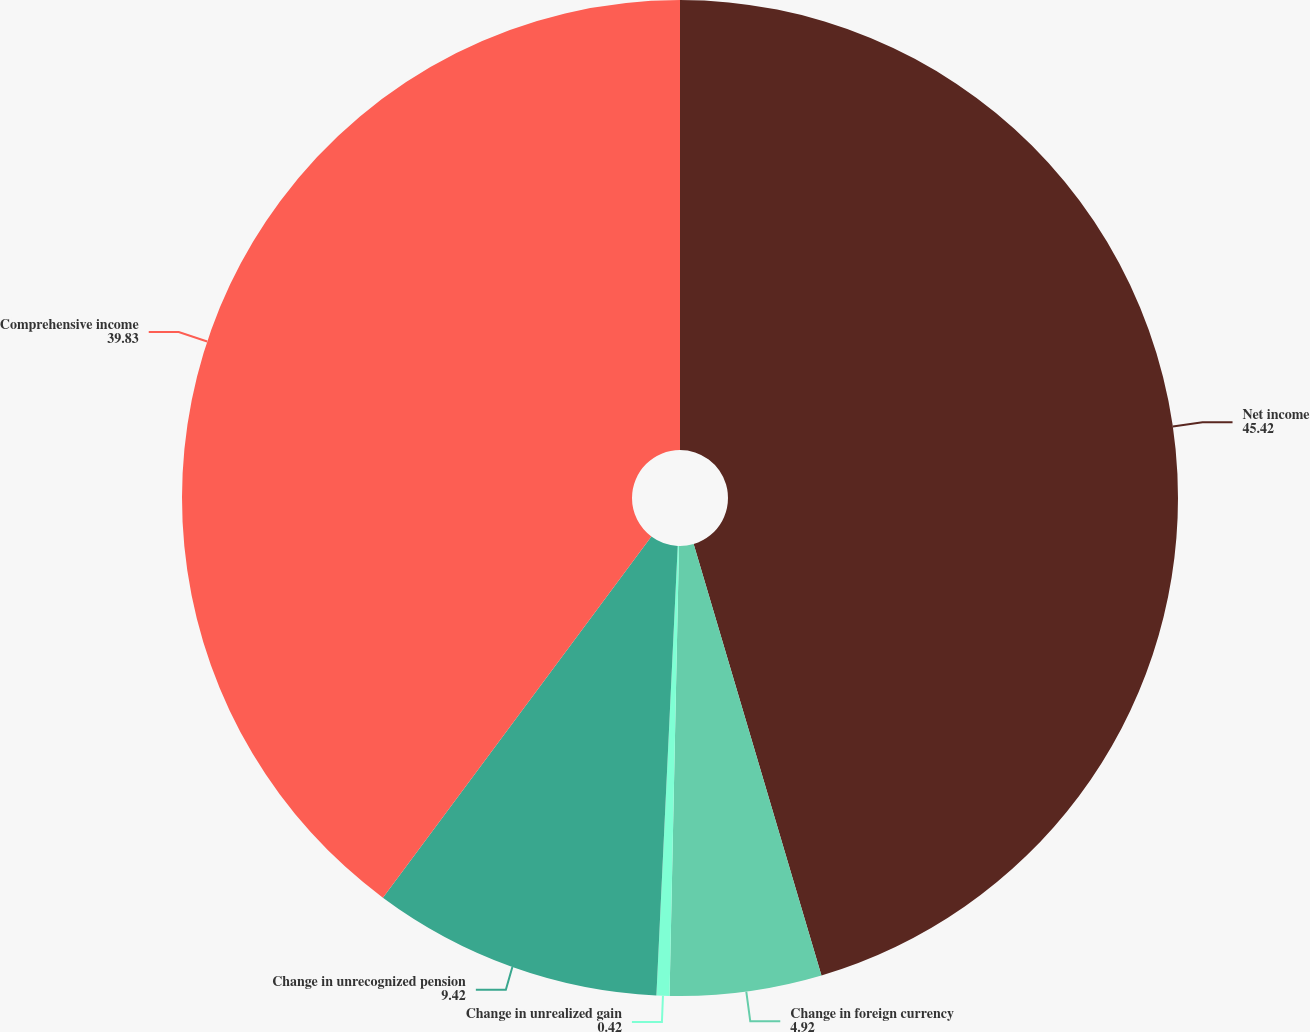<chart> <loc_0><loc_0><loc_500><loc_500><pie_chart><fcel>Net income<fcel>Change in foreign currency<fcel>Change in unrealized gain<fcel>Change in unrecognized pension<fcel>Comprehensive income<nl><fcel>45.42%<fcel>4.92%<fcel>0.42%<fcel>9.42%<fcel>39.83%<nl></chart> 